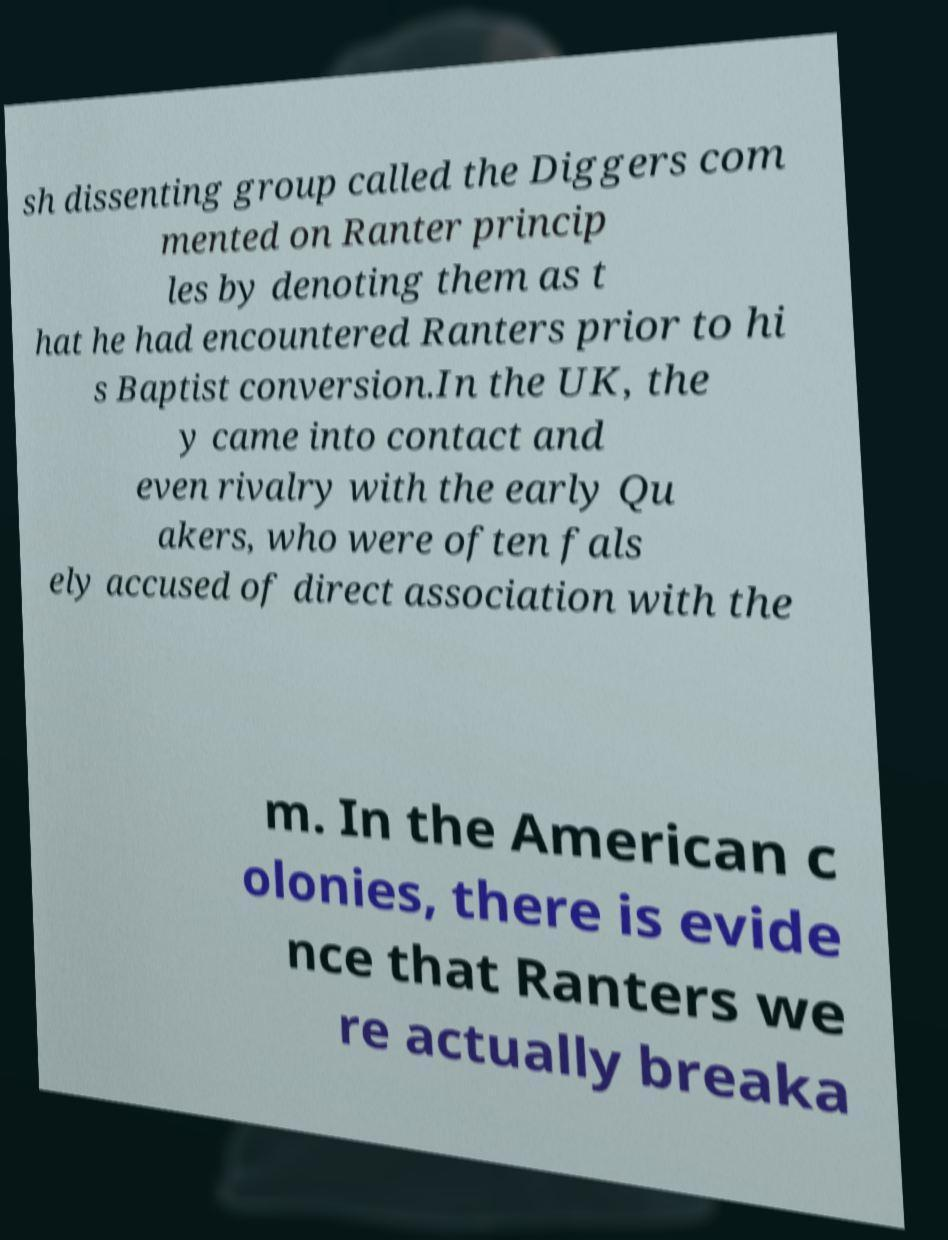Please read and relay the text visible in this image. What does it say? sh dissenting group called the Diggers com mented on Ranter princip les by denoting them as t hat he had encountered Ranters prior to hi s Baptist conversion.In the UK, the y came into contact and even rivalry with the early Qu akers, who were often fals ely accused of direct association with the m. In the American c olonies, there is evide nce that Ranters we re actually breaka 